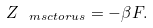<formula> <loc_0><loc_0><loc_500><loc_500>Z _ { \ m s c { t o r u s } } = - \beta F .</formula> 